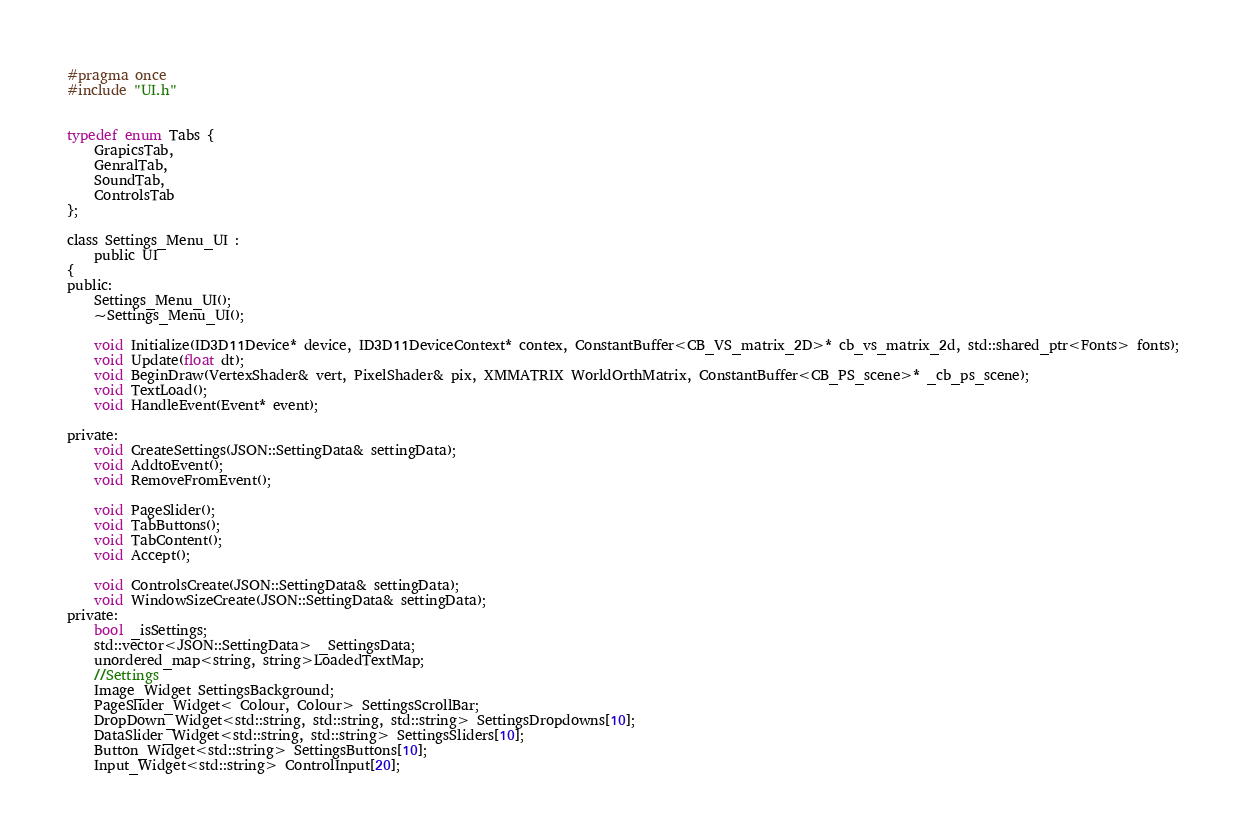<code> <loc_0><loc_0><loc_500><loc_500><_C_>#pragma once
#include "UI.h"


typedef enum Tabs {
	GrapicsTab,
	GenralTab,
	SoundTab,
	ControlsTab
};

class Settings_Menu_UI :
    public UI
{
public:
	Settings_Menu_UI();
	~Settings_Menu_UI();

	void Initialize(ID3D11Device* device, ID3D11DeviceContext* contex, ConstantBuffer<CB_VS_matrix_2D>* cb_vs_matrix_2d, std::shared_ptr<Fonts> fonts);
	void Update(float dt);
	void BeginDraw(VertexShader& vert, PixelShader& pix, XMMATRIX WorldOrthMatrix, ConstantBuffer<CB_PS_scene>* _cb_ps_scene);
	void TextLoad();
	void HandleEvent(Event* event);

private:
	void CreateSettings(JSON::SettingData& settingData);
	void AddtoEvent();
	void RemoveFromEvent();

	void PageSlider();
	void TabButtons();
	void TabContent();
	void Accept();

	void ControlsCreate(JSON::SettingData& settingData);
	void WindowSizeCreate(JSON::SettingData& settingData);
private:
	bool _isSettings;
	std::vector<JSON::SettingData> _SettingsData;
	unordered_map<string, string>LoadedTextMap;
	//Settings
	Image_Widget SettingsBackground;
	PageSlider_Widget< Colour, Colour> SettingsScrollBar;
	DropDown_Widget<std::string, std::string, std::string> SettingsDropdowns[10];
	DataSlider_Widget<std::string, std::string> SettingsSliders[10];
	Button_Widget<std::string> SettingsButtons[10];
	Input_Widget<std::string> ControlInput[20];</code> 